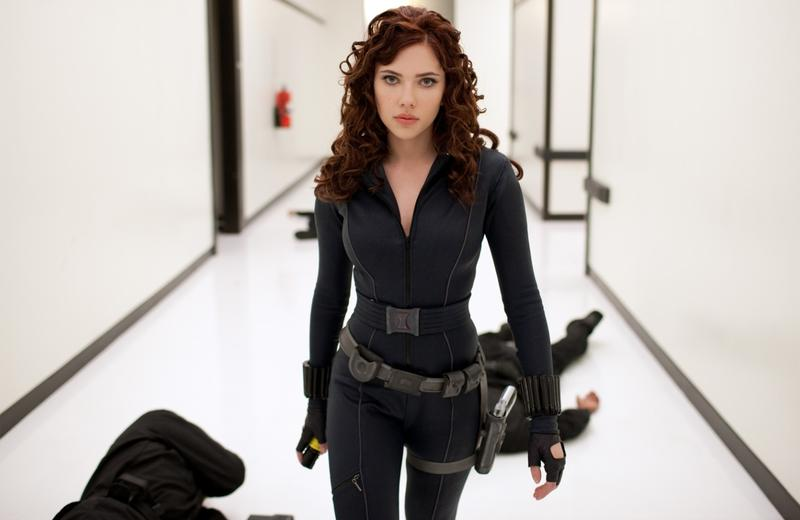Analyze the image in a comprehensive and detailed manner. The image portrays a scene featuring a character that closely resembles a well-known superhero, Black Widow. She stands confidently in a stark white hallway, the walls and floor of which are lined with black lines that add a sense of depth and perspective to the scene. Dressed in a sleek black jumpsuit, which features utility belts and holsters, she embodies strength and determination. Her loosely curled hair provides a contrast to her otherwise stern and focused demeanor. Her intense gaze off to the side suggests a moment of deep thought or readiness for upcoming action. Lying on the ground in the background are two individuals, indicating a recent confrontation and highlighting her formidable combat skills. 